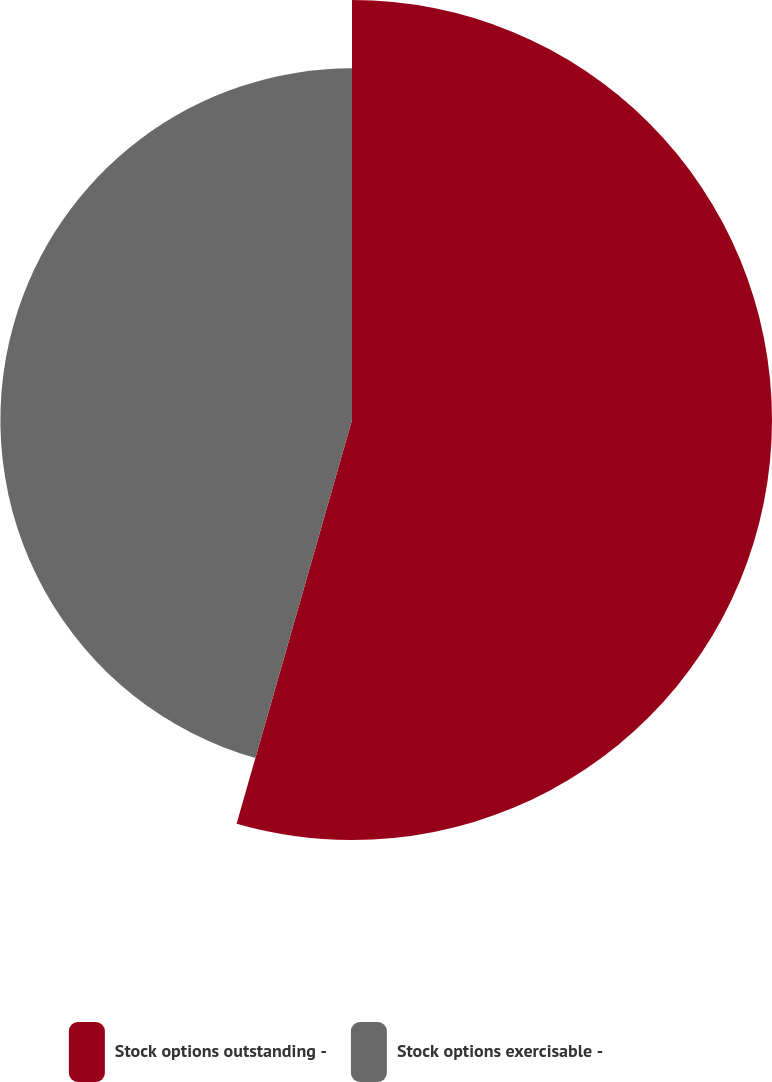<chart> <loc_0><loc_0><loc_500><loc_500><pie_chart><fcel>Stock options outstanding -<fcel>Stock options exercisable -<nl><fcel>54.43%<fcel>45.57%<nl></chart> 